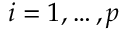<formula> <loc_0><loc_0><loc_500><loc_500>i = 1 , \dots , p</formula> 